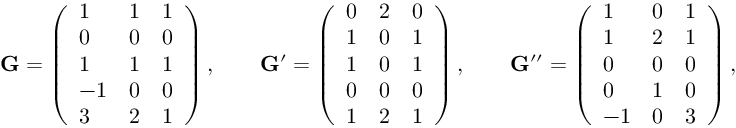Convert formula to latex. <formula><loc_0><loc_0><loc_500><loc_500>\mathbf G = \left ( \begin{array} { l l l } { 1 } & { 1 } & { 1 } \\ { 0 } & { 0 } & { 0 } \\ { 1 } & { 1 } & { 1 } \\ { - 1 } & { 0 } & { 0 } \\ { 3 } & { 2 } & { 1 } \end{array} \right ) , \quad \mathbf G ^ { \prime } = \left ( \begin{array} { l l l } { 0 } & { 2 } & { 0 } \\ { 1 } & { 0 } & { 1 } \\ { 1 } & { 0 } & { 1 } \\ { 0 } & { 0 } & { 0 } \\ { 1 } & { 2 } & { 1 } \end{array} \right ) , \quad \mathbf G ^ { \prime \prime } = \left ( \begin{array} { l l l } { 1 } & { 0 } & { 1 } \\ { 1 } & { 2 } & { 1 } \\ { 0 } & { 0 } & { 0 } \\ { 0 } & { 1 } & { 0 } \\ { - 1 } & { 0 } & { 3 } \end{array} \right ) ,</formula> 